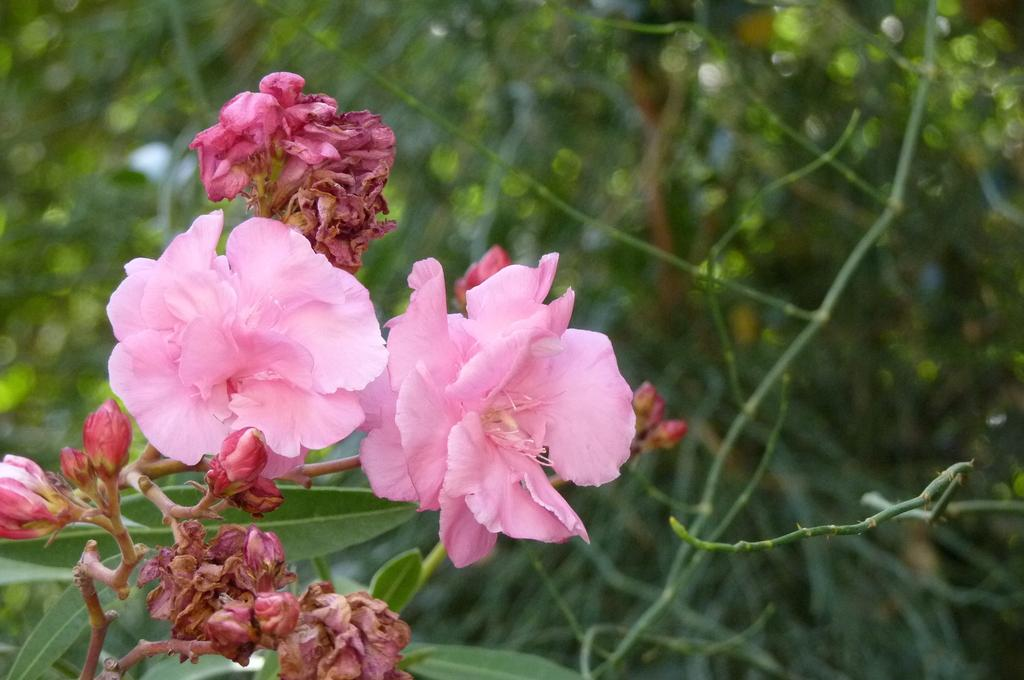What type of vegetation can be seen on the left side of the image? There are flowers on the left side of the image. What can be seen in the background of the image? There are plants visible in the background of the image. What type of territory does the knowledge blow in the image? There is no mention of territory, blowing, or knowledge in the image. 